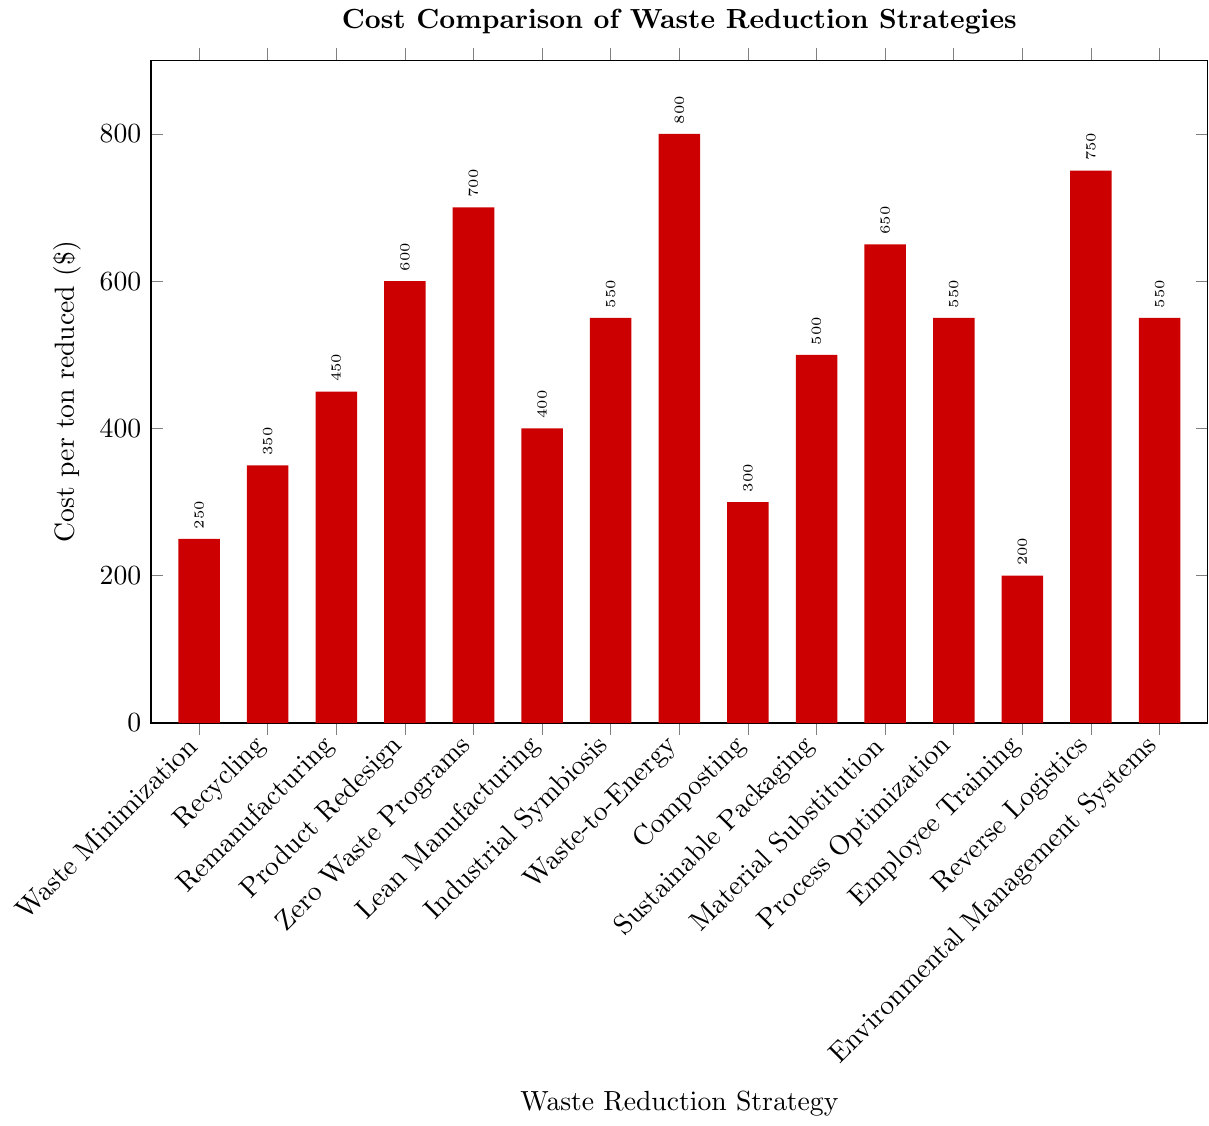Which waste reduction strategy has the lowest cost per ton reduced? The strategy with the lowest cost per ton reduced is the one with the shortest bar in the bar chart. By observing the height of the bars, "Employee Training" appears to have the lowest cost at $200 per ton reduced
Answer: Employee Training Which strategy is more costly per ton reduced, Waste-to-Energy or Lean Manufacturing? To determine which strategy is more costly, compare the heights of the bars for Waste-to-Energy and Lean Manufacturing. Waste-to-Energy has a cost of $800 per ton reduced while Lean Manufacturing has a cost of $400 per ton reduced, making Waste-to-Energy more costly
Answer: Waste-to-Energy How much more expensive is Product Redesign compared to Composting per ton reduced? To find the difference in cost per ton reduced, subtract the cost of Composting from the cost of Product Redesign. Product Redesign costs $600 per ton reduced while Composting costs $300 per ton reduced. Therefore, the difference is $600 - $300 = $300
Answer: $300 What is the average cost per ton reduced for the strategies that cost more than $500 per ton reduced? First, identify the strategies costing more than $500 per ton reduced: Zero Waste Programs ($700), Waste-to-Energy ($800), Material Substitution ($650), Reverse Logistics ($750), Process Optimization ($550), Industrial Symbiosis ($550), and Environmental Management Systems ($550). Sum these costs: 700 + 800 + 650 + 750 + 550 + 550 + 550 = 4550. There are 7 strategies, so the average cost is 4550 / 7 = ~650
Answer: ~650 Are there more strategies with costs above $500 per ton reduced or below $500 per ton reduced? Count the number of strategies above and below $500 per ton. Above $500: Zero Waste Programs, Waste-to-Energy, Material Substitution, Reverse Logistics, Process Optimization, Industrial Symbiosis, Environmental Management Systems (7 strategies). Below $500: Waste Minimization, Recycling, Remanufacturing, Lean Manufacturing, Composting, Sustainable Packaging, Employee Training (7 strategies). Both counts are equal
Answer: Equal Which strategy has a cost color indicated by green and what is its cost per ton reduced? In the figure, green corresponds to the second fill color in the cycle list. The second bar in the bar chart, colored green, is Recycling. Recycling has a cost of $350 per ton reduced
Answer: Recycling, $350 What are the total costs per ton reduced if the costs of Lean Manufacturing, Sustainable Packaging, and Environmental Management Systems are summed? Sum the costs of the mentioned strategies: Lean Manufacturing ($400), Sustainable Packaging ($500), and Environmental Management Systems ($550). The total is 400 + 500 + 550 = $1450
Answer: $1450 Which strategies have the same cost per ton reduced? Observe the bars that reach the same height to identify strategies with equal costs. Industrial Symbiosis, Process Optimization, and Environmental Management Systems each have a cost of $550 per ton reduced
Answer: Industrial Symbiosis, Process Optimization, Environmental Management Systems Among Waste Minimization, Recycling, and Remanufacturing, which strategy is the most cost-effective per ton reduced? Compare the costs per ton reduced for the mentioned strategies. Waste Minimization ($250), Recycling ($350), and Remanufacturing ($450). Waste Minimization has the lowest cost, making it the most cost-effective
Answer: Waste Minimization What is the difference in cost per ton reduced between the most expensive and the least expensive strategy? Identify the most expensive and least expensive strategies and find their cost difference. Waste-to-Energy is the most expensive at $800 per ton reduced and Employee Training is the least expensive at $200 per ton reduced. The difference is $800 - $200 = $600
Answer: $600 